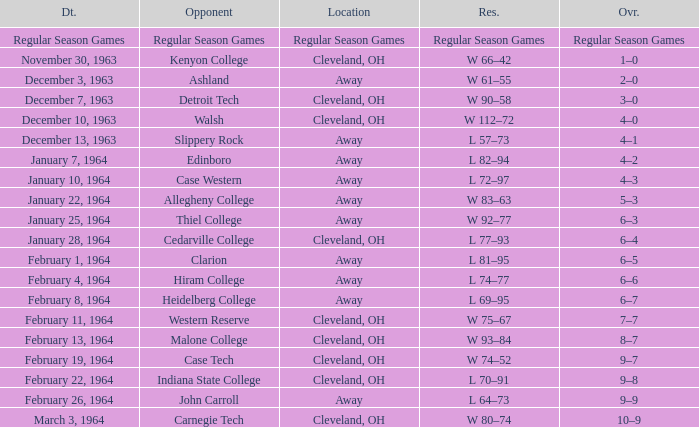What is the Date with an Opponent that is indiana state college? February 22, 1964. 